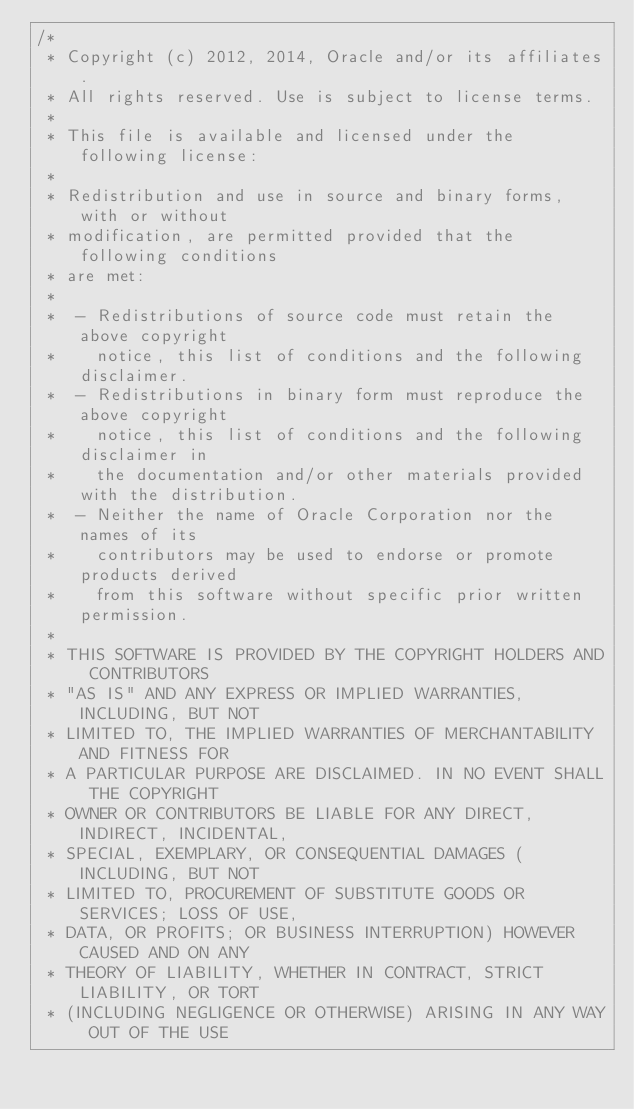<code> <loc_0><loc_0><loc_500><loc_500><_Java_>/*
 * Copyright (c) 2012, 2014, Oracle and/or its affiliates.
 * All rights reserved. Use is subject to license terms.
 *
 * This file is available and licensed under the following license:
 *
 * Redistribution and use in source and binary forms, with or without
 * modification, are permitted provided that the following conditions
 * are met:
 *
 *  - Redistributions of source code must retain the above copyright
 *    notice, this list of conditions and the following disclaimer.
 *  - Redistributions in binary form must reproduce the above copyright
 *    notice, this list of conditions and the following disclaimer in
 *    the documentation and/or other materials provided with the distribution.
 *  - Neither the name of Oracle Corporation nor the names of its
 *    contributors may be used to endorse or promote products derived
 *    from this software without specific prior written permission.
 *
 * THIS SOFTWARE IS PROVIDED BY THE COPYRIGHT HOLDERS AND CONTRIBUTORS
 * "AS IS" AND ANY EXPRESS OR IMPLIED WARRANTIES, INCLUDING, BUT NOT
 * LIMITED TO, THE IMPLIED WARRANTIES OF MERCHANTABILITY AND FITNESS FOR
 * A PARTICULAR PURPOSE ARE DISCLAIMED. IN NO EVENT SHALL THE COPYRIGHT
 * OWNER OR CONTRIBUTORS BE LIABLE FOR ANY DIRECT, INDIRECT, INCIDENTAL,
 * SPECIAL, EXEMPLARY, OR CONSEQUENTIAL DAMAGES (INCLUDING, BUT NOT
 * LIMITED TO, PROCUREMENT OF SUBSTITUTE GOODS OR SERVICES; LOSS OF USE,
 * DATA, OR PROFITS; OR BUSINESS INTERRUPTION) HOWEVER CAUSED AND ON ANY
 * THEORY OF LIABILITY, WHETHER IN CONTRACT, STRICT LIABILITY, OR TORT
 * (INCLUDING NEGLIGENCE OR OTHERWISE) ARISING IN ANY WAY OUT OF THE USE</code> 